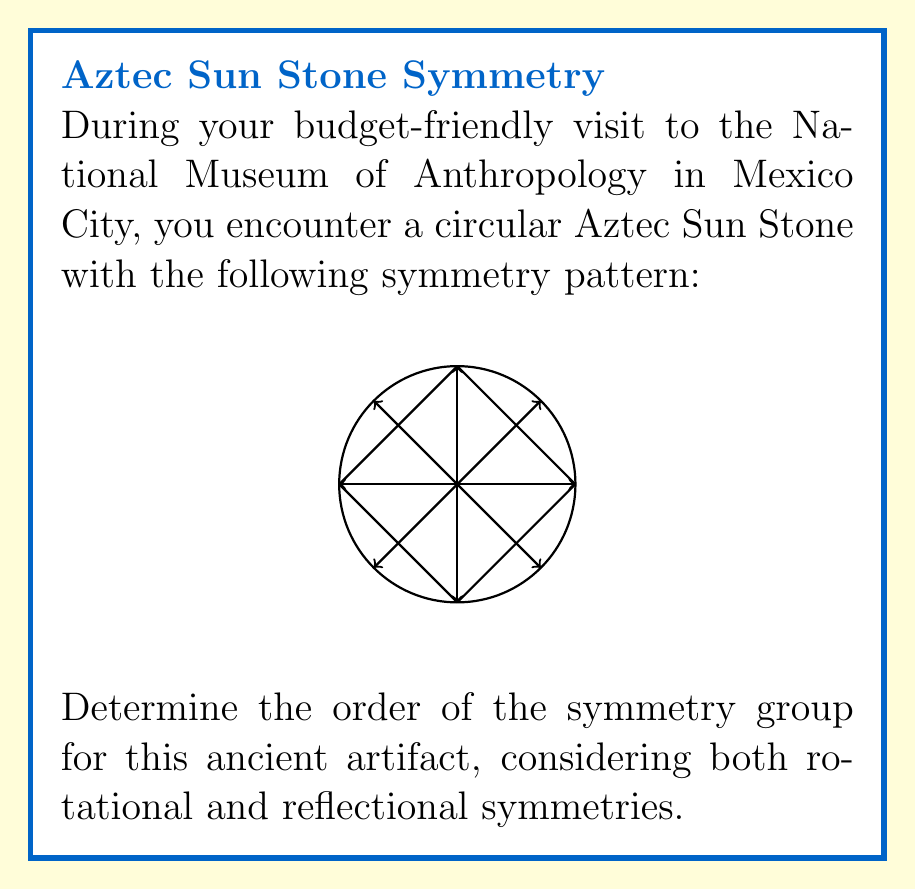Give your solution to this math problem. Let's approach this step-by-step:

1) First, we need to identify the symmetries present in the Sun Stone:

   a) Rotational symmetries: The stone has 8 arrows pointing outward, indicating 8-fold rotational symmetry. This means we can rotate the stone by multiples of 45° (360°/8) and it will look the same.

   b) Reflectional symmetries: The stone has 4 lines of reflection (the perpendicular lines shown).

2) To determine the order of the symmetry group, we need to count the total number of distinct symmetry operations:

   a) Rotations: We have 8 rotations (including the identity rotation):
      $$\{0°, 45°, 90°, 135°, 180°, 225°, 270°, 315°\}$$

   b) Reflections: We have 4 reflections.

3) The total number of symmetry operations is the sum of rotations and reflections:
   $$8 + 4 = 12$$

4) In group theory, this symmetry group is known as the dihedral group $D_8$, where the subscript 8 refers to the number of rotational symmetries.

5) The order of a group is the number of elements in the group. In this case, it's the total number of symmetry operations we counted.

Therefore, the order of the symmetry group for this Aztec Sun Stone is 12.
Answer: 12 